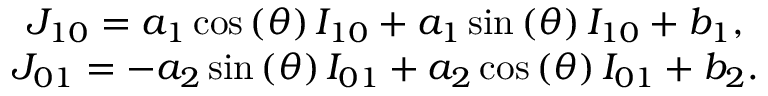Convert formula to latex. <formula><loc_0><loc_0><loc_500><loc_500>\begin{array} { c } { { J _ { 1 0 } } = { a _ { 1 } } \cos \left ( \theta \right ) { I _ { 1 0 } } + { a _ { 1 } } \sin \left ( \theta \right ) { I _ { 1 0 } } + { b _ { 1 } } , } \\ { { J _ { 0 1 } } = - { a _ { 2 } } \sin \left ( \theta \right ) { I _ { 0 1 } } + { a _ { 2 } } \cos \left ( \theta \right ) { I _ { 0 1 } } + { b _ { 2 } } . } \end{array}</formula> 